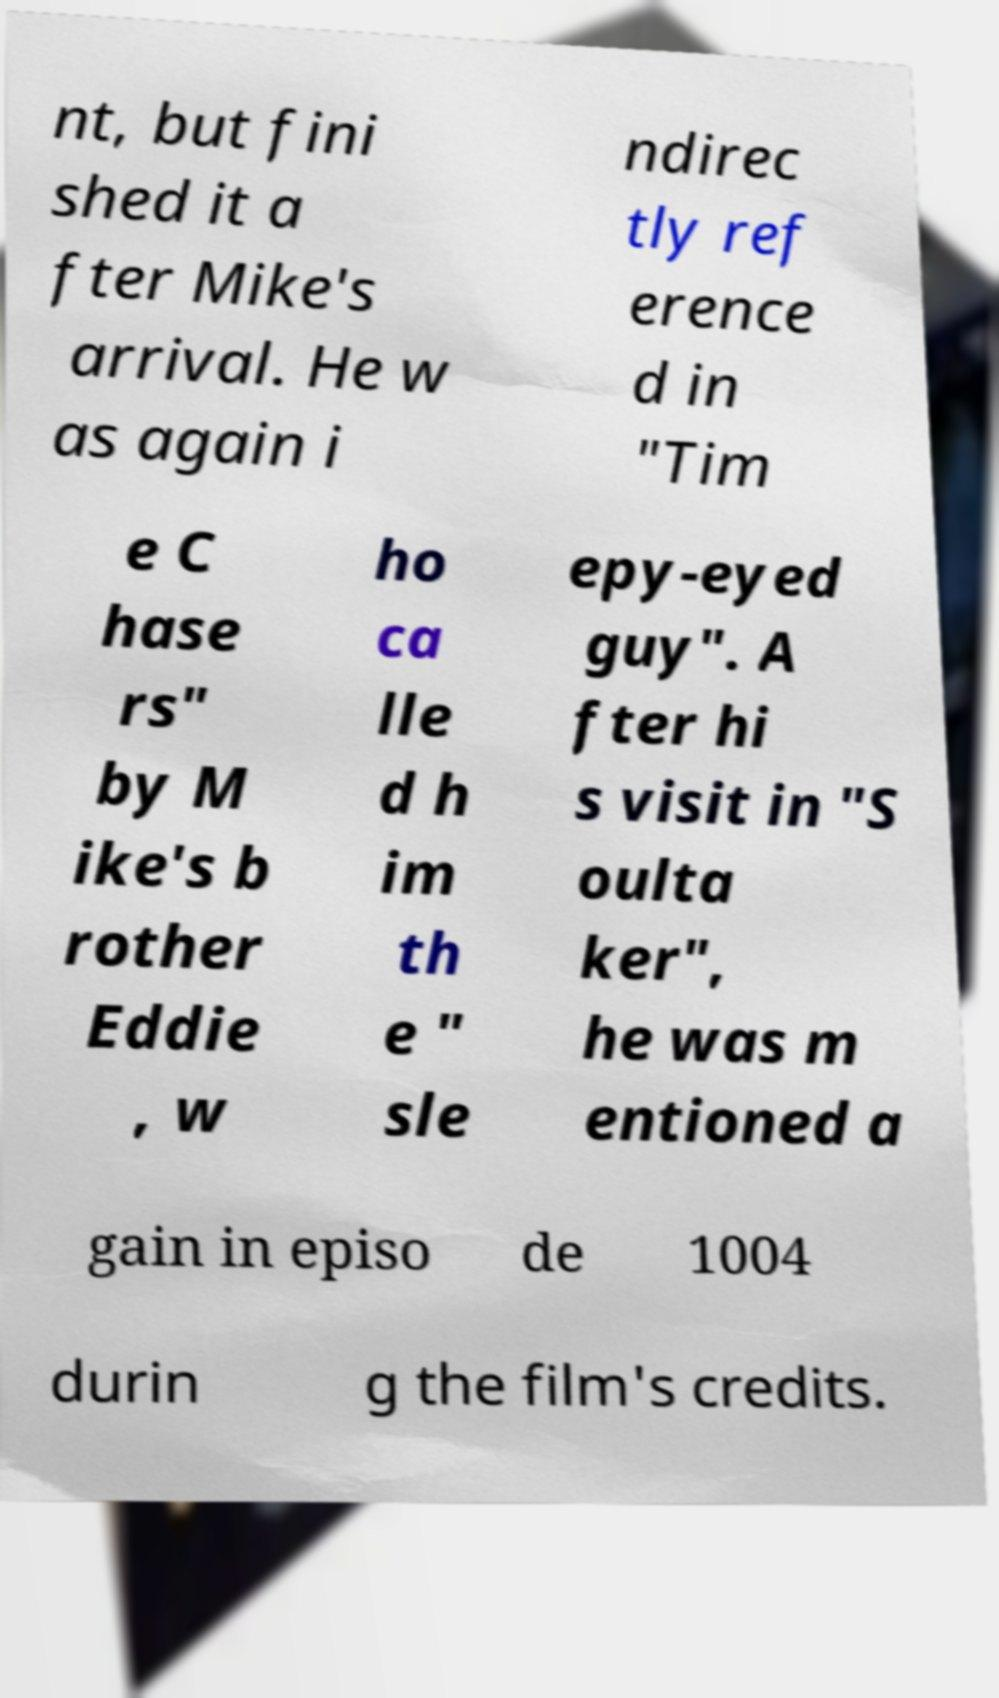Could you assist in decoding the text presented in this image and type it out clearly? nt, but fini shed it a fter Mike's arrival. He w as again i ndirec tly ref erence d in "Tim e C hase rs" by M ike's b rother Eddie , w ho ca lle d h im th e " sle epy-eyed guy". A fter hi s visit in "S oulta ker", he was m entioned a gain in episo de 1004 durin g the film's credits. 